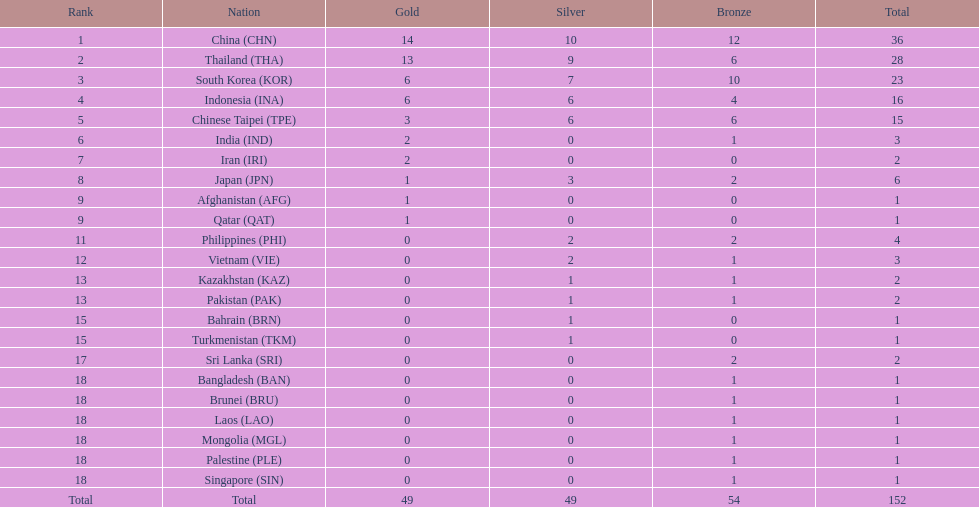What was the number of medals earned by indonesia (ina) ? 16. 